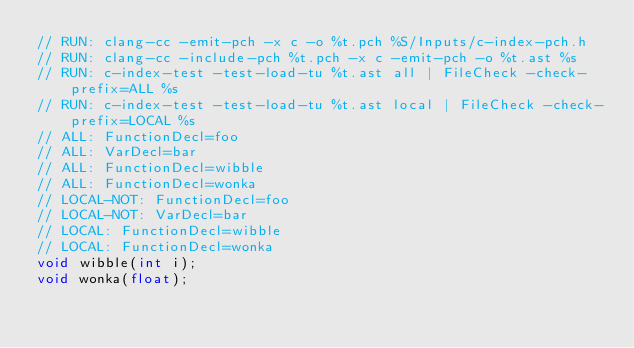<code> <loc_0><loc_0><loc_500><loc_500><_C_>// RUN: clang-cc -emit-pch -x c -o %t.pch %S/Inputs/c-index-pch.h
// RUN: clang-cc -include-pch %t.pch -x c -emit-pch -o %t.ast %s
// RUN: c-index-test -test-load-tu %t.ast all | FileCheck -check-prefix=ALL %s
// RUN: c-index-test -test-load-tu %t.ast local | FileCheck -check-prefix=LOCAL %s
// ALL: FunctionDecl=foo
// ALL: VarDecl=bar
// ALL: FunctionDecl=wibble
// ALL: FunctionDecl=wonka
// LOCAL-NOT: FunctionDecl=foo
// LOCAL-NOT: VarDecl=bar
// LOCAL: FunctionDecl=wibble
// LOCAL: FunctionDecl=wonka
void wibble(int i);
void wonka(float);
</code> 